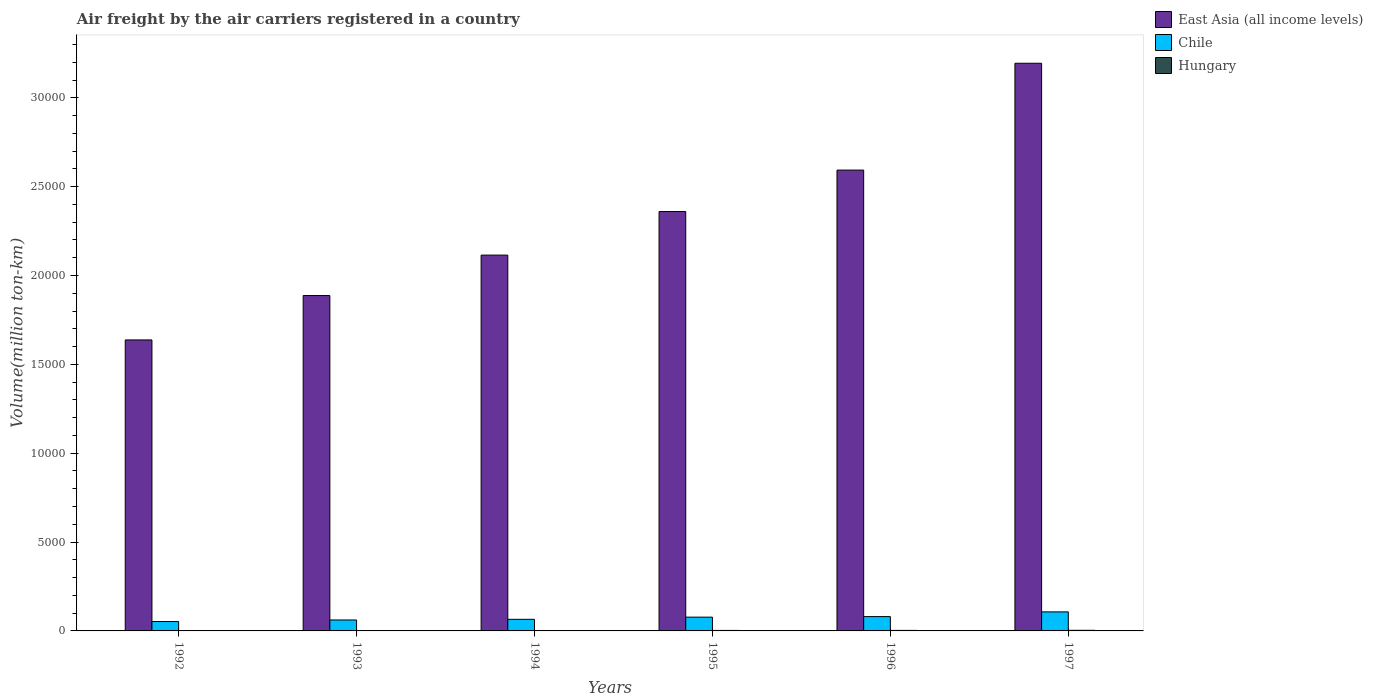How many different coloured bars are there?
Keep it short and to the point. 3. How many groups of bars are there?
Ensure brevity in your answer.  6. Are the number of bars per tick equal to the number of legend labels?
Your answer should be very brief. Yes. How many bars are there on the 6th tick from the left?
Keep it short and to the point. 3. In how many cases, is the number of bars for a given year not equal to the number of legend labels?
Your answer should be very brief. 0. Across all years, what is the maximum volume of the air carriers in Chile?
Offer a very short reply. 1071.2. Across all years, what is the minimum volume of the air carriers in Chile?
Provide a short and direct response. 529. In which year was the volume of the air carriers in East Asia (all income levels) minimum?
Ensure brevity in your answer.  1992. What is the total volume of the air carriers in Hungary in the graph?
Your answer should be compact. 127.4. What is the difference between the volume of the air carriers in East Asia (all income levels) in 1994 and that in 1995?
Provide a succinct answer. -2451.4. What is the difference between the volume of the air carriers in Hungary in 1996 and the volume of the air carriers in East Asia (all income levels) in 1995?
Offer a very short reply. -2.36e+04. What is the average volume of the air carriers in Hungary per year?
Offer a very short reply. 21.23. In the year 1994, what is the difference between the volume of the air carriers in Chile and volume of the air carriers in East Asia (all income levels)?
Make the answer very short. -2.05e+04. What is the ratio of the volume of the air carriers in Chile in 1993 to that in 1995?
Keep it short and to the point. 0.79. Is the difference between the volume of the air carriers in Chile in 1993 and 1994 greater than the difference between the volume of the air carriers in East Asia (all income levels) in 1993 and 1994?
Offer a very short reply. Yes. What is the difference between the highest and the second highest volume of the air carriers in Hungary?
Give a very brief answer. 5.6. What is the difference between the highest and the lowest volume of the air carriers in Hungary?
Give a very brief answer. 28.4. How many bars are there?
Give a very brief answer. 18. Are all the bars in the graph horizontal?
Your response must be concise. No. How many years are there in the graph?
Make the answer very short. 6. Are the values on the major ticks of Y-axis written in scientific E-notation?
Provide a succinct answer. No. Does the graph contain any zero values?
Make the answer very short. No. Where does the legend appear in the graph?
Provide a succinct answer. Top right. How are the legend labels stacked?
Ensure brevity in your answer.  Vertical. What is the title of the graph?
Offer a very short reply. Air freight by the air carriers registered in a country. What is the label or title of the Y-axis?
Make the answer very short. Volume(million ton-km). What is the Volume(million ton-km) in East Asia (all income levels) in 1992?
Ensure brevity in your answer.  1.64e+04. What is the Volume(million ton-km) of Chile in 1992?
Your response must be concise. 529. What is the Volume(million ton-km) in East Asia (all income levels) in 1993?
Your answer should be very brief. 1.89e+04. What is the Volume(million ton-km) in Chile in 1993?
Provide a succinct answer. 616.2. What is the Volume(million ton-km) in East Asia (all income levels) in 1994?
Give a very brief answer. 2.11e+04. What is the Volume(million ton-km) in Chile in 1994?
Offer a terse response. 652.5. What is the Volume(million ton-km) of Hungary in 1994?
Your answer should be compact. 17.7. What is the Volume(million ton-km) of East Asia (all income levels) in 1995?
Provide a succinct answer. 2.36e+04. What is the Volume(million ton-km) of Chile in 1995?
Keep it short and to the point. 775.4. What is the Volume(million ton-km) in Hungary in 1995?
Provide a succinct answer. 28.5. What is the Volume(million ton-km) of East Asia (all income levels) in 1996?
Offer a very short reply. 2.59e+04. What is the Volume(million ton-km) of Chile in 1996?
Offer a very short reply. 806.2. What is the Volume(million ton-km) in Hungary in 1996?
Ensure brevity in your answer.  29.3. What is the Volume(million ton-km) in East Asia (all income levels) in 1997?
Provide a succinct answer. 3.19e+04. What is the Volume(million ton-km) of Chile in 1997?
Make the answer very short. 1071.2. What is the Volume(million ton-km) in Hungary in 1997?
Offer a terse response. 34.9. Across all years, what is the maximum Volume(million ton-km) of East Asia (all income levels)?
Keep it short and to the point. 3.19e+04. Across all years, what is the maximum Volume(million ton-km) of Chile?
Make the answer very short. 1071.2. Across all years, what is the maximum Volume(million ton-km) of Hungary?
Keep it short and to the point. 34.9. Across all years, what is the minimum Volume(million ton-km) of East Asia (all income levels)?
Offer a very short reply. 1.64e+04. Across all years, what is the minimum Volume(million ton-km) of Chile?
Ensure brevity in your answer.  529. What is the total Volume(million ton-km) of East Asia (all income levels) in the graph?
Your answer should be very brief. 1.38e+05. What is the total Volume(million ton-km) of Chile in the graph?
Your response must be concise. 4450.5. What is the total Volume(million ton-km) in Hungary in the graph?
Provide a succinct answer. 127.4. What is the difference between the Volume(million ton-km) of East Asia (all income levels) in 1992 and that in 1993?
Provide a succinct answer. -2497.5. What is the difference between the Volume(million ton-km) in Chile in 1992 and that in 1993?
Keep it short and to the point. -87.2. What is the difference between the Volume(million ton-km) in Hungary in 1992 and that in 1993?
Provide a succinct answer. -4. What is the difference between the Volume(million ton-km) in East Asia (all income levels) in 1992 and that in 1994?
Keep it short and to the point. -4773.1. What is the difference between the Volume(million ton-km) of Chile in 1992 and that in 1994?
Your answer should be very brief. -123.5. What is the difference between the Volume(million ton-km) in East Asia (all income levels) in 1992 and that in 1995?
Offer a very short reply. -7224.5. What is the difference between the Volume(million ton-km) in Chile in 1992 and that in 1995?
Your answer should be very brief. -246.4. What is the difference between the Volume(million ton-km) of East Asia (all income levels) in 1992 and that in 1996?
Make the answer very short. -9557.5. What is the difference between the Volume(million ton-km) in Chile in 1992 and that in 1996?
Your answer should be compact. -277.2. What is the difference between the Volume(million ton-km) in Hungary in 1992 and that in 1996?
Your response must be concise. -22.8. What is the difference between the Volume(million ton-km) of East Asia (all income levels) in 1992 and that in 1997?
Your response must be concise. -1.56e+04. What is the difference between the Volume(million ton-km) in Chile in 1992 and that in 1997?
Provide a short and direct response. -542.2. What is the difference between the Volume(million ton-km) in Hungary in 1992 and that in 1997?
Your answer should be very brief. -28.4. What is the difference between the Volume(million ton-km) of East Asia (all income levels) in 1993 and that in 1994?
Ensure brevity in your answer.  -2275.6. What is the difference between the Volume(million ton-km) in Chile in 1993 and that in 1994?
Ensure brevity in your answer.  -36.3. What is the difference between the Volume(million ton-km) in East Asia (all income levels) in 1993 and that in 1995?
Your answer should be very brief. -4727. What is the difference between the Volume(million ton-km) of Chile in 1993 and that in 1995?
Provide a succinct answer. -159.2. What is the difference between the Volume(million ton-km) of Hungary in 1993 and that in 1995?
Make the answer very short. -18. What is the difference between the Volume(million ton-km) in East Asia (all income levels) in 1993 and that in 1996?
Keep it short and to the point. -7060. What is the difference between the Volume(million ton-km) of Chile in 1993 and that in 1996?
Your answer should be compact. -190. What is the difference between the Volume(million ton-km) in Hungary in 1993 and that in 1996?
Your response must be concise. -18.8. What is the difference between the Volume(million ton-km) of East Asia (all income levels) in 1993 and that in 1997?
Provide a short and direct response. -1.31e+04. What is the difference between the Volume(million ton-km) of Chile in 1993 and that in 1997?
Make the answer very short. -455. What is the difference between the Volume(million ton-km) in Hungary in 1993 and that in 1997?
Your answer should be very brief. -24.4. What is the difference between the Volume(million ton-km) in East Asia (all income levels) in 1994 and that in 1995?
Ensure brevity in your answer.  -2451.4. What is the difference between the Volume(million ton-km) of Chile in 1994 and that in 1995?
Your answer should be compact. -122.9. What is the difference between the Volume(million ton-km) of Hungary in 1994 and that in 1995?
Make the answer very short. -10.8. What is the difference between the Volume(million ton-km) of East Asia (all income levels) in 1994 and that in 1996?
Offer a very short reply. -4784.4. What is the difference between the Volume(million ton-km) in Chile in 1994 and that in 1996?
Ensure brevity in your answer.  -153.7. What is the difference between the Volume(million ton-km) in Hungary in 1994 and that in 1996?
Provide a succinct answer. -11.6. What is the difference between the Volume(million ton-km) of East Asia (all income levels) in 1994 and that in 1997?
Make the answer very short. -1.08e+04. What is the difference between the Volume(million ton-km) in Chile in 1994 and that in 1997?
Your response must be concise. -418.7. What is the difference between the Volume(million ton-km) of Hungary in 1994 and that in 1997?
Offer a very short reply. -17.2. What is the difference between the Volume(million ton-km) in East Asia (all income levels) in 1995 and that in 1996?
Your response must be concise. -2333. What is the difference between the Volume(million ton-km) in Chile in 1995 and that in 1996?
Give a very brief answer. -30.8. What is the difference between the Volume(million ton-km) in Hungary in 1995 and that in 1996?
Provide a succinct answer. -0.8. What is the difference between the Volume(million ton-km) of East Asia (all income levels) in 1995 and that in 1997?
Your answer should be very brief. -8344.2. What is the difference between the Volume(million ton-km) of Chile in 1995 and that in 1997?
Your answer should be very brief. -295.8. What is the difference between the Volume(million ton-km) in Hungary in 1995 and that in 1997?
Your answer should be compact. -6.4. What is the difference between the Volume(million ton-km) in East Asia (all income levels) in 1996 and that in 1997?
Give a very brief answer. -6011.2. What is the difference between the Volume(million ton-km) in Chile in 1996 and that in 1997?
Provide a short and direct response. -265. What is the difference between the Volume(million ton-km) in Hungary in 1996 and that in 1997?
Offer a very short reply. -5.6. What is the difference between the Volume(million ton-km) in East Asia (all income levels) in 1992 and the Volume(million ton-km) in Chile in 1993?
Ensure brevity in your answer.  1.58e+04. What is the difference between the Volume(million ton-km) in East Asia (all income levels) in 1992 and the Volume(million ton-km) in Hungary in 1993?
Your answer should be very brief. 1.64e+04. What is the difference between the Volume(million ton-km) of Chile in 1992 and the Volume(million ton-km) of Hungary in 1993?
Offer a terse response. 518.5. What is the difference between the Volume(million ton-km) of East Asia (all income levels) in 1992 and the Volume(million ton-km) of Chile in 1994?
Your answer should be very brief. 1.57e+04. What is the difference between the Volume(million ton-km) of East Asia (all income levels) in 1992 and the Volume(million ton-km) of Hungary in 1994?
Your answer should be compact. 1.64e+04. What is the difference between the Volume(million ton-km) in Chile in 1992 and the Volume(million ton-km) in Hungary in 1994?
Your answer should be very brief. 511.3. What is the difference between the Volume(million ton-km) of East Asia (all income levels) in 1992 and the Volume(million ton-km) of Chile in 1995?
Provide a succinct answer. 1.56e+04. What is the difference between the Volume(million ton-km) of East Asia (all income levels) in 1992 and the Volume(million ton-km) of Hungary in 1995?
Make the answer very short. 1.63e+04. What is the difference between the Volume(million ton-km) in Chile in 1992 and the Volume(million ton-km) in Hungary in 1995?
Make the answer very short. 500.5. What is the difference between the Volume(million ton-km) in East Asia (all income levels) in 1992 and the Volume(million ton-km) in Chile in 1996?
Ensure brevity in your answer.  1.56e+04. What is the difference between the Volume(million ton-km) in East Asia (all income levels) in 1992 and the Volume(million ton-km) in Hungary in 1996?
Your answer should be compact. 1.63e+04. What is the difference between the Volume(million ton-km) in Chile in 1992 and the Volume(million ton-km) in Hungary in 1996?
Your response must be concise. 499.7. What is the difference between the Volume(million ton-km) in East Asia (all income levels) in 1992 and the Volume(million ton-km) in Chile in 1997?
Offer a terse response. 1.53e+04. What is the difference between the Volume(million ton-km) in East Asia (all income levels) in 1992 and the Volume(million ton-km) in Hungary in 1997?
Give a very brief answer. 1.63e+04. What is the difference between the Volume(million ton-km) in Chile in 1992 and the Volume(million ton-km) in Hungary in 1997?
Provide a succinct answer. 494.1. What is the difference between the Volume(million ton-km) of East Asia (all income levels) in 1993 and the Volume(million ton-km) of Chile in 1994?
Provide a short and direct response. 1.82e+04. What is the difference between the Volume(million ton-km) of East Asia (all income levels) in 1993 and the Volume(million ton-km) of Hungary in 1994?
Give a very brief answer. 1.89e+04. What is the difference between the Volume(million ton-km) in Chile in 1993 and the Volume(million ton-km) in Hungary in 1994?
Ensure brevity in your answer.  598.5. What is the difference between the Volume(million ton-km) in East Asia (all income levels) in 1993 and the Volume(million ton-km) in Chile in 1995?
Offer a terse response. 1.81e+04. What is the difference between the Volume(million ton-km) of East Asia (all income levels) in 1993 and the Volume(million ton-km) of Hungary in 1995?
Offer a terse response. 1.88e+04. What is the difference between the Volume(million ton-km) of Chile in 1993 and the Volume(million ton-km) of Hungary in 1995?
Ensure brevity in your answer.  587.7. What is the difference between the Volume(million ton-km) of East Asia (all income levels) in 1993 and the Volume(million ton-km) of Chile in 1996?
Your answer should be very brief. 1.81e+04. What is the difference between the Volume(million ton-km) of East Asia (all income levels) in 1993 and the Volume(million ton-km) of Hungary in 1996?
Ensure brevity in your answer.  1.88e+04. What is the difference between the Volume(million ton-km) in Chile in 1993 and the Volume(million ton-km) in Hungary in 1996?
Your answer should be compact. 586.9. What is the difference between the Volume(million ton-km) in East Asia (all income levels) in 1993 and the Volume(million ton-km) in Chile in 1997?
Keep it short and to the point. 1.78e+04. What is the difference between the Volume(million ton-km) in East Asia (all income levels) in 1993 and the Volume(million ton-km) in Hungary in 1997?
Give a very brief answer. 1.88e+04. What is the difference between the Volume(million ton-km) of Chile in 1993 and the Volume(million ton-km) of Hungary in 1997?
Your response must be concise. 581.3. What is the difference between the Volume(million ton-km) in East Asia (all income levels) in 1994 and the Volume(million ton-km) in Chile in 1995?
Ensure brevity in your answer.  2.04e+04. What is the difference between the Volume(million ton-km) in East Asia (all income levels) in 1994 and the Volume(million ton-km) in Hungary in 1995?
Your response must be concise. 2.11e+04. What is the difference between the Volume(million ton-km) in Chile in 1994 and the Volume(million ton-km) in Hungary in 1995?
Make the answer very short. 624. What is the difference between the Volume(million ton-km) in East Asia (all income levels) in 1994 and the Volume(million ton-km) in Chile in 1996?
Provide a short and direct response. 2.03e+04. What is the difference between the Volume(million ton-km) of East Asia (all income levels) in 1994 and the Volume(million ton-km) of Hungary in 1996?
Give a very brief answer. 2.11e+04. What is the difference between the Volume(million ton-km) of Chile in 1994 and the Volume(million ton-km) of Hungary in 1996?
Ensure brevity in your answer.  623.2. What is the difference between the Volume(million ton-km) in East Asia (all income levels) in 1994 and the Volume(million ton-km) in Chile in 1997?
Ensure brevity in your answer.  2.01e+04. What is the difference between the Volume(million ton-km) of East Asia (all income levels) in 1994 and the Volume(million ton-km) of Hungary in 1997?
Provide a succinct answer. 2.11e+04. What is the difference between the Volume(million ton-km) in Chile in 1994 and the Volume(million ton-km) in Hungary in 1997?
Offer a very short reply. 617.6. What is the difference between the Volume(million ton-km) of East Asia (all income levels) in 1995 and the Volume(million ton-km) of Chile in 1996?
Your answer should be compact. 2.28e+04. What is the difference between the Volume(million ton-km) in East Asia (all income levels) in 1995 and the Volume(million ton-km) in Hungary in 1996?
Ensure brevity in your answer.  2.36e+04. What is the difference between the Volume(million ton-km) in Chile in 1995 and the Volume(million ton-km) in Hungary in 1996?
Ensure brevity in your answer.  746.1. What is the difference between the Volume(million ton-km) of East Asia (all income levels) in 1995 and the Volume(million ton-km) of Chile in 1997?
Keep it short and to the point. 2.25e+04. What is the difference between the Volume(million ton-km) in East Asia (all income levels) in 1995 and the Volume(million ton-km) in Hungary in 1997?
Your answer should be compact. 2.36e+04. What is the difference between the Volume(million ton-km) of Chile in 1995 and the Volume(million ton-km) of Hungary in 1997?
Make the answer very short. 740.5. What is the difference between the Volume(million ton-km) of East Asia (all income levels) in 1996 and the Volume(million ton-km) of Chile in 1997?
Make the answer very short. 2.49e+04. What is the difference between the Volume(million ton-km) in East Asia (all income levels) in 1996 and the Volume(million ton-km) in Hungary in 1997?
Offer a very short reply. 2.59e+04. What is the difference between the Volume(million ton-km) in Chile in 1996 and the Volume(million ton-km) in Hungary in 1997?
Provide a short and direct response. 771.3. What is the average Volume(million ton-km) of East Asia (all income levels) per year?
Offer a very short reply. 2.30e+04. What is the average Volume(million ton-km) of Chile per year?
Provide a short and direct response. 741.75. What is the average Volume(million ton-km) in Hungary per year?
Give a very brief answer. 21.23. In the year 1992, what is the difference between the Volume(million ton-km) in East Asia (all income levels) and Volume(million ton-km) in Chile?
Your response must be concise. 1.58e+04. In the year 1992, what is the difference between the Volume(million ton-km) in East Asia (all income levels) and Volume(million ton-km) in Hungary?
Ensure brevity in your answer.  1.64e+04. In the year 1992, what is the difference between the Volume(million ton-km) in Chile and Volume(million ton-km) in Hungary?
Make the answer very short. 522.5. In the year 1993, what is the difference between the Volume(million ton-km) of East Asia (all income levels) and Volume(million ton-km) of Chile?
Give a very brief answer. 1.83e+04. In the year 1993, what is the difference between the Volume(million ton-km) of East Asia (all income levels) and Volume(million ton-km) of Hungary?
Keep it short and to the point. 1.89e+04. In the year 1993, what is the difference between the Volume(million ton-km) in Chile and Volume(million ton-km) in Hungary?
Your answer should be very brief. 605.7. In the year 1994, what is the difference between the Volume(million ton-km) in East Asia (all income levels) and Volume(million ton-km) in Chile?
Offer a very short reply. 2.05e+04. In the year 1994, what is the difference between the Volume(million ton-km) of East Asia (all income levels) and Volume(million ton-km) of Hungary?
Provide a short and direct response. 2.11e+04. In the year 1994, what is the difference between the Volume(million ton-km) of Chile and Volume(million ton-km) of Hungary?
Provide a succinct answer. 634.8. In the year 1995, what is the difference between the Volume(million ton-km) in East Asia (all income levels) and Volume(million ton-km) in Chile?
Provide a succinct answer. 2.28e+04. In the year 1995, what is the difference between the Volume(million ton-km) of East Asia (all income levels) and Volume(million ton-km) of Hungary?
Offer a very short reply. 2.36e+04. In the year 1995, what is the difference between the Volume(million ton-km) of Chile and Volume(million ton-km) of Hungary?
Keep it short and to the point. 746.9. In the year 1996, what is the difference between the Volume(million ton-km) of East Asia (all income levels) and Volume(million ton-km) of Chile?
Offer a terse response. 2.51e+04. In the year 1996, what is the difference between the Volume(million ton-km) of East Asia (all income levels) and Volume(million ton-km) of Hungary?
Ensure brevity in your answer.  2.59e+04. In the year 1996, what is the difference between the Volume(million ton-km) in Chile and Volume(million ton-km) in Hungary?
Keep it short and to the point. 776.9. In the year 1997, what is the difference between the Volume(million ton-km) in East Asia (all income levels) and Volume(million ton-km) in Chile?
Your answer should be very brief. 3.09e+04. In the year 1997, what is the difference between the Volume(million ton-km) in East Asia (all income levels) and Volume(million ton-km) in Hungary?
Offer a very short reply. 3.19e+04. In the year 1997, what is the difference between the Volume(million ton-km) in Chile and Volume(million ton-km) in Hungary?
Your answer should be very brief. 1036.3. What is the ratio of the Volume(million ton-km) of East Asia (all income levels) in 1992 to that in 1993?
Make the answer very short. 0.87. What is the ratio of the Volume(million ton-km) in Chile in 1992 to that in 1993?
Make the answer very short. 0.86. What is the ratio of the Volume(million ton-km) in Hungary in 1992 to that in 1993?
Offer a terse response. 0.62. What is the ratio of the Volume(million ton-km) in East Asia (all income levels) in 1992 to that in 1994?
Offer a terse response. 0.77. What is the ratio of the Volume(million ton-km) in Chile in 1992 to that in 1994?
Your answer should be compact. 0.81. What is the ratio of the Volume(million ton-km) in Hungary in 1992 to that in 1994?
Offer a very short reply. 0.37. What is the ratio of the Volume(million ton-km) of East Asia (all income levels) in 1992 to that in 1995?
Your answer should be compact. 0.69. What is the ratio of the Volume(million ton-km) of Chile in 1992 to that in 1995?
Offer a terse response. 0.68. What is the ratio of the Volume(million ton-km) in Hungary in 1992 to that in 1995?
Offer a terse response. 0.23. What is the ratio of the Volume(million ton-km) in East Asia (all income levels) in 1992 to that in 1996?
Your answer should be compact. 0.63. What is the ratio of the Volume(million ton-km) of Chile in 1992 to that in 1996?
Your answer should be very brief. 0.66. What is the ratio of the Volume(million ton-km) of Hungary in 1992 to that in 1996?
Make the answer very short. 0.22. What is the ratio of the Volume(million ton-km) of East Asia (all income levels) in 1992 to that in 1997?
Ensure brevity in your answer.  0.51. What is the ratio of the Volume(million ton-km) of Chile in 1992 to that in 1997?
Offer a very short reply. 0.49. What is the ratio of the Volume(million ton-km) of Hungary in 1992 to that in 1997?
Make the answer very short. 0.19. What is the ratio of the Volume(million ton-km) of East Asia (all income levels) in 1993 to that in 1994?
Ensure brevity in your answer.  0.89. What is the ratio of the Volume(million ton-km) of Hungary in 1993 to that in 1994?
Keep it short and to the point. 0.59. What is the ratio of the Volume(million ton-km) in East Asia (all income levels) in 1993 to that in 1995?
Provide a short and direct response. 0.8. What is the ratio of the Volume(million ton-km) of Chile in 1993 to that in 1995?
Keep it short and to the point. 0.79. What is the ratio of the Volume(million ton-km) in Hungary in 1993 to that in 1995?
Make the answer very short. 0.37. What is the ratio of the Volume(million ton-km) of East Asia (all income levels) in 1993 to that in 1996?
Provide a short and direct response. 0.73. What is the ratio of the Volume(million ton-km) in Chile in 1993 to that in 1996?
Your answer should be compact. 0.76. What is the ratio of the Volume(million ton-km) of Hungary in 1993 to that in 1996?
Your answer should be very brief. 0.36. What is the ratio of the Volume(million ton-km) of East Asia (all income levels) in 1993 to that in 1997?
Give a very brief answer. 0.59. What is the ratio of the Volume(million ton-km) in Chile in 1993 to that in 1997?
Ensure brevity in your answer.  0.58. What is the ratio of the Volume(million ton-km) in Hungary in 1993 to that in 1997?
Offer a terse response. 0.3. What is the ratio of the Volume(million ton-km) of East Asia (all income levels) in 1994 to that in 1995?
Provide a short and direct response. 0.9. What is the ratio of the Volume(million ton-km) of Chile in 1994 to that in 1995?
Ensure brevity in your answer.  0.84. What is the ratio of the Volume(million ton-km) of Hungary in 1994 to that in 1995?
Provide a short and direct response. 0.62. What is the ratio of the Volume(million ton-km) in East Asia (all income levels) in 1994 to that in 1996?
Provide a succinct answer. 0.82. What is the ratio of the Volume(million ton-km) in Chile in 1994 to that in 1996?
Give a very brief answer. 0.81. What is the ratio of the Volume(million ton-km) in Hungary in 1994 to that in 1996?
Give a very brief answer. 0.6. What is the ratio of the Volume(million ton-km) of East Asia (all income levels) in 1994 to that in 1997?
Ensure brevity in your answer.  0.66. What is the ratio of the Volume(million ton-km) in Chile in 1994 to that in 1997?
Offer a very short reply. 0.61. What is the ratio of the Volume(million ton-km) in Hungary in 1994 to that in 1997?
Provide a short and direct response. 0.51. What is the ratio of the Volume(million ton-km) in East Asia (all income levels) in 1995 to that in 1996?
Offer a terse response. 0.91. What is the ratio of the Volume(million ton-km) in Chile in 1995 to that in 1996?
Offer a very short reply. 0.96. What is the ratio of the Volume(million ton-km) in Hungary in 1995 to that in 1996?
Provide a short and direct response. 0.97. What is the ratio of the Volume(million ton-km) in East Asia (all income levels) in 1995 to that in 1997?
Provide a short and direct response. 0.74. What is the ratio of the Volume(million ton-km) of Chile in 1995 to that in 1997?
Make the answer very short. 0.72. What is the ratio of the Volume(million ton-km) in Hungary in 1995 to that in 1997?
Keep it short and to the point. 0.82. What is the ratio of the Volume(million ton-km) in East Asia (all income levels) in 1996 to that in 1997?
Your response must be concise. 0.81. What is the ratio of the Volume(million ton-km) of Chile in 1996 to that in 1997?
Ensure brevity in your answer.  0.75. What is the ratio of the Volume(million ton-km) of Hungary in 1996 to that in 1997?
Your response must be concise. 0.84. What is the difference between the highest and the second highest Volume(million ton-km) in East Asia (all income levels)?
Offer a terse response. 6011.2. What is the difference between the highest and the second highest Volume(million ton-km) in Chile?
Offer a very short reply. 265. What is the difference between the highest and the lowest Volume(million ton-km) of East Asia (all income levels)?
Give a very brief answer. 1.56e+04. What is the difference between the highest and the lowest Volume(million ton-km) in Chile?
Provide a succinct answer. 542.2. What is the difference between the highest and the lowest Volume(million ton-km) of Hungary?
Give a very brief answer. 28.4. 